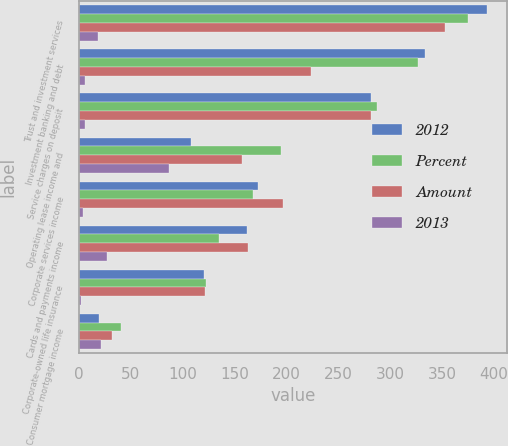<chart> <loc_0><loc_0><loc_500><loc_500><stacked_bar_chart><ecel><fcel>Trust and investment services<fcel>Investment banking and debt<fcel>Service charges on deposit<fcel>Operating lease income and<fcel>Corporate services income<fcel>Cards and payments income<fcel>Corporate-owned life insurance<fcel>Consumer mortgage income<nl><fcel>2012<fcel>393<fcel>333<fcel>281<fcel>108<fcel>172<fcel>162<fcel>120<fcel>19<nl><fcel>Percent<fcel>375<fcel>327<fcel>287<fcel>195<fcel>168<fcel>135<fcel>122<fcel>40<nl><fcel>Amount<fcel>353<fcel>224<fcel>281<fcel>157<fcel>197<fcel>163<fcel>121<fcel>32<nl><fcel>2013<fcel>18<fcel>6<fcel>6<fcel>87<fcel>4<fcel>27<fcel>2<fcel>21<nl></chart> 